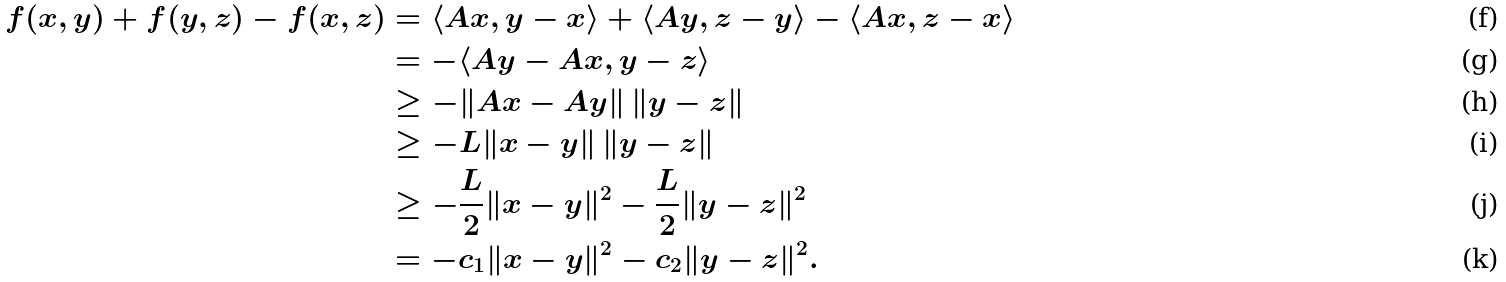Convert formula to latex. <formula><loc_0><loc_0><loc_500><loc_500>f ( x , y ) + f ( y , z ) - f ( x , z ) & = \langle A x , y - x \rangle + \langle A y , z - y \rangle - \langle A x , z - x \rangle \\ & = - \langle A y - A x , y - z \rangle \\ & \geq - \| A x - A y \| \left \| y - z \right \| \\ & \geq - L \| x - y \| \left \| y - z \right \| \\ & \geq - \frac { L } { 2 } \| x - y \| ^ { 2 } - \frac { L } { 2 } \| y - z \| ^ { 2 } \\ & = - c _ { 1 } \| x - y \| ^ { 2 } - c _ { 2 } \| y - z \| ^ { 2 } .</formula> 